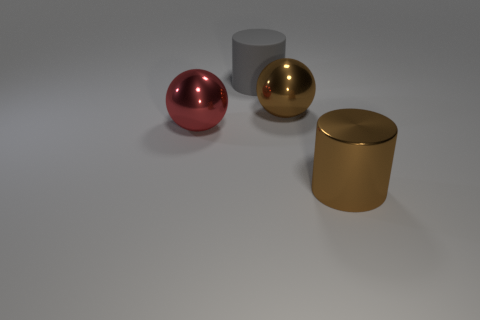Add 2 large cylinders. How many objects exist? 6 Subtract 0 green spheres. How many objects are left? 4 Subtract all brown metallic spheres. Subtract all big cyan balls. How many objects are left? 3 Add 1 big gray cylinders. How many big gray cylinders are left? 2 Add 2 brown shiny cylinders. How many brown shiny cylinders exist? 3 